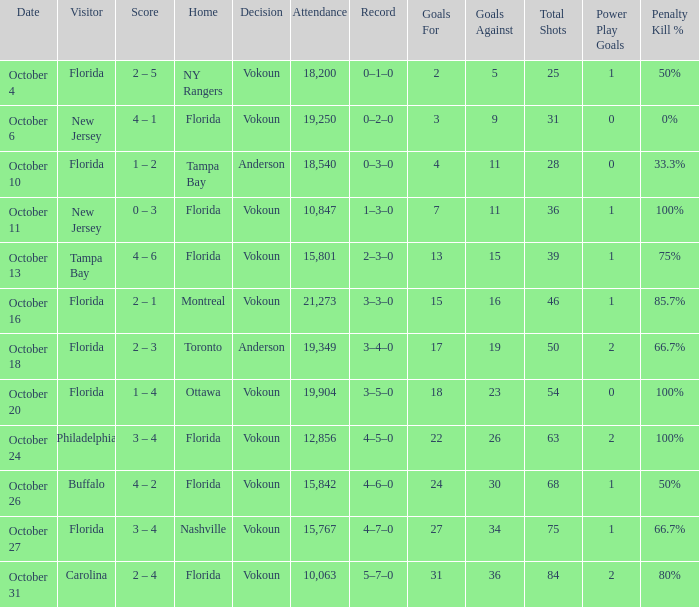What was the score on October 13? 4 – 6. 